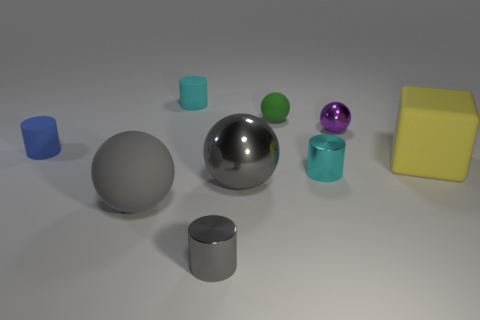Subtract all blue cylinders. How many cylinders are left? 3 Subtract all green balls. How many balls are left? 3 Subtract all balls. How many objects are left? 5 Subtract all yellow spheres. How many blue cubes are left? 0 Subtract all blocks. Subtract all cyan metallic cylinders. How many objects are left? 7 Add 2 blue rubber cylinders. How many blue rubber cylinders are left? 3 Add 3 small purple metallic spheres. How many small purple metallic spheres exist? 4 Subtract 0 blue blocks. How many objects are left? 9 Subtract 1 spheres. How many spheres are left? 3 Subtract all brown cylinders. Subtract all purple blocks. How many cylinders are left? 4 